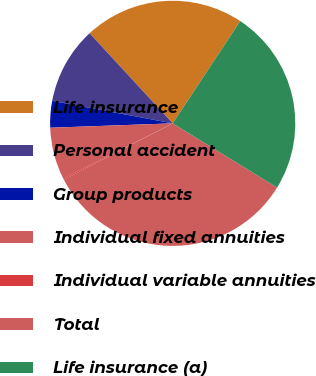Convert chart. <chart><loc_0><loc_0><loc_500><loc_500><pie_chart><fcel>Life insurance<fcel>Personal accident<fcel>Group products<fcel>Individual fixed annuities<fcel>Individual variable annuities<fcel>Total<fcel>Life insurance (a)<nl><fcel>21.15%<fcel>10.2%<fcel>3.51%<fcel>6.86%<fcel>0.17%<fcel>33.62%<fcel>24.49%<nl></chart> 